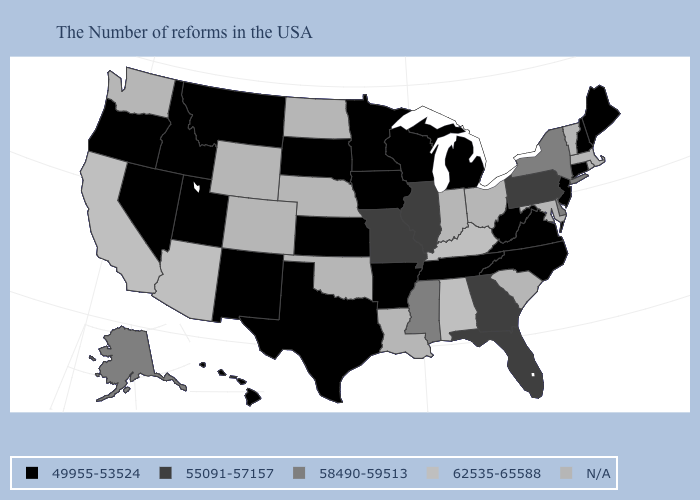Which states hav the highest value in the Northeast?
Answer briefly. New York. Name the states that have a value in the range 55091-57157?
Keep it brief. Pennsylvania, Florida, Georgia, Illinois, Missouri. Which states have the lowest value in the MidWest?
Be succinct. Michigan, Wisconsin, Minnesota, Iowa, Kansas, South Dakota. Name the states that have a value in the range 58490-59513?
Be succinct. New York, Delaware, Mississippi, Alaska. What is the value of Texas?
Be succinct. 49955-53524. What is the value of Arizona?
Quick response, please. 62535-65588. Name the states that have a value in the range N/A?
Keep it brief. Massachusetts, Rhode Island, Vermont, Maryland, South Carolina, Ohio, Indiana, Louisiana, Nebraska, Oklahoma, North Dakota, Wyoming, Colorado, Washington. Is the legend a continuous bar?
Concise answer only. No. What is the value of New Jersey?
Short answer required. 49955-53524. Name the states that have a value in the range 55091-57157?
Quick response, please. Pennsylvania, Florida, Georgia, Illinois, Missouri. Does the first symbol in the legend represent the smallest category?
Answer briefly. Yes. Which states have the lowest value in the USA?
Give a very brief answer. Maine, New Hampshire, Connecticut, New Jersey, Virginia, North Carolina, West Virginia, Michigan, Tennessee, Wisconsin, Arkansas, Minnesota, Iowa, Kansas, Texas, South Dakota, New Mexico, Utah, Montana, Idaho, Nevada, Oregon, Hawaii. What is the lowest value in the South?
Keep it brief. 49955-53524. Name the states that have a value in the range 49955-53524?
Keep it brief. Maine, New Hampshire, Connecticut, New Jersey, Virginia, North Carolina, West Virginia, Michigan, Tennessee, Wisconsin, Arkansas, Minnesota, Iowa, Kansas, Texas, South Dakota, New Mexico, Utah, Montana, Idaho, Nevada, Oregon, Hawaii. 